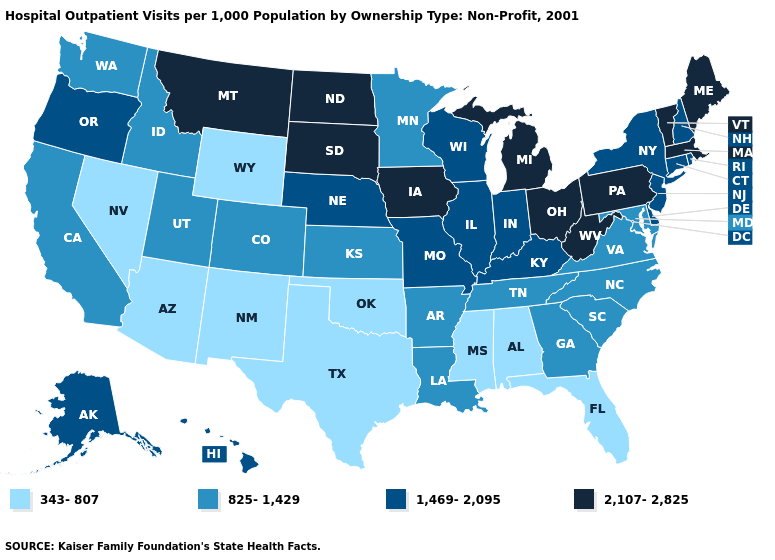What is the highest value in the West ?
Concise answer only. 2,107-2,825. Name the states that have a value in the range 825-1,429?
Be succinct. Arkansas, California, Colorado, Georgia, Idaho, Kansas, Louisiana, Maryland, Minnesota, North Carolina, South Carolina, Tennessee, Utah, Virginia, Washington. Which states have the highest value in the USA?
Concise answer only. Iowa, Maine, Massachusetts, Michigan, Montana, North Dakota, Ohio, Pennsylvania, South Dakota, Vermont, West Virginia. Name the states that have a value in the range 825-1,429?
Keep it brief. Arkansas, California, Colorado, Georgia, Idaho, Kansas, Louisiana, Maryland, Minnesota, North Carolina, South Carolina, Tennessee, Utah, Virginia, Washington. What is the highest value in the USA?
Keep it brief. 2,107-2,825. What is the value of Idaho?
Be succinct. 825-1,429. Which states hav the highest value in the South?
Quick response, please. West Virginia. Does the map have missing data?
Be succinct. No. What is the value of Wisconsin?
Give a very brief answer. 1,469-2,095. What is the value of Hawaii?
Keep it brief. 1,469-2,095. Name the states that have a value in the range 1,469-2,095?
Give a very brief answer. Alaska, Connecticut, Delaware, Hawaii, Illinois, Indiana, Kentucky, Missouri, Nebraska, New Hampshire, New Jersey, New York, Oregon, Rhode Island, Wisconsin. Is the legend a continuous bar?
Quick response, please. No. Name the states that have a value in the range 343-807?
Keep it brief. Alabama, Arizona, Florida, Mississippi, Nevada, New Mexico, Oklahoma, Texas, Wyoming. What is the value of Tennessee?
Answer briefly. 825-1,429. Name the states that have a value in the range 825-1,429?
Keep it brief. Arkansas, California, Colorado, Georgia, Idaho, Kansas, Louisiana, Maryland, Minnesota, North Carolina, South Carolina, Tennessee, Utah, Virginia, Washington. 